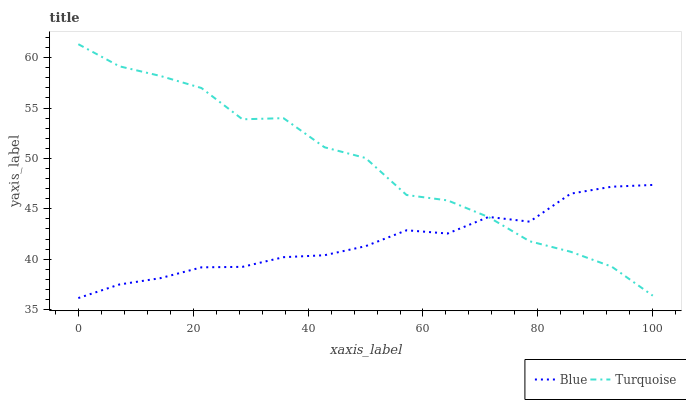Does Blue have the minimum area under the curve?
Answer yes or no. Yes. Does Turquoise have the maximum area under the curve?
Answer yes or no. Yes. Does Turquoise have the minimum area under the curve?
Answer yes or no. No. Is Blue the smoothest?
Answer yes or no. Yes. Is Turquoise the roughest?
Answer yes or no. Yes. Is Turquoise the smoothest?
Answer yes or no. No. Does Blue have the lowest value?
Answer yes or no. Yes. Does Turquoise have the lowest value?
Answer yes or no. No. Does Turquoise have the highest value?
Answer yes or no. Yes. Does Blue intersect Turquoise?
Answer yes or no. Yes. Is Blue less than Turquoise?
Answer yes or no. No. Is Blue greater than Turquoise?
Answer yes or no. No. 